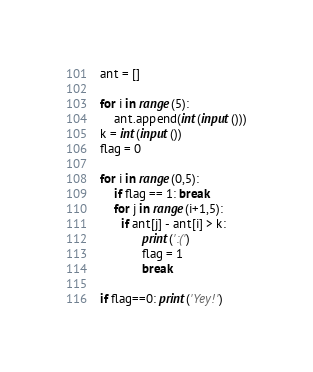<code> <loc_0><loc_0><loc_500><loc_500><_Python_>ant = []

for i in range(5):
    ant.append(int(input()))
k = int(input())
flag = 0

for i in range(0,5):
    if flag == 1: break
    for j in range(i+1,5):
      if ant[j] - ant[i] > k:
            print(':(')
            flag = 1
            break

if flag==0: print('Yey!')</code> 